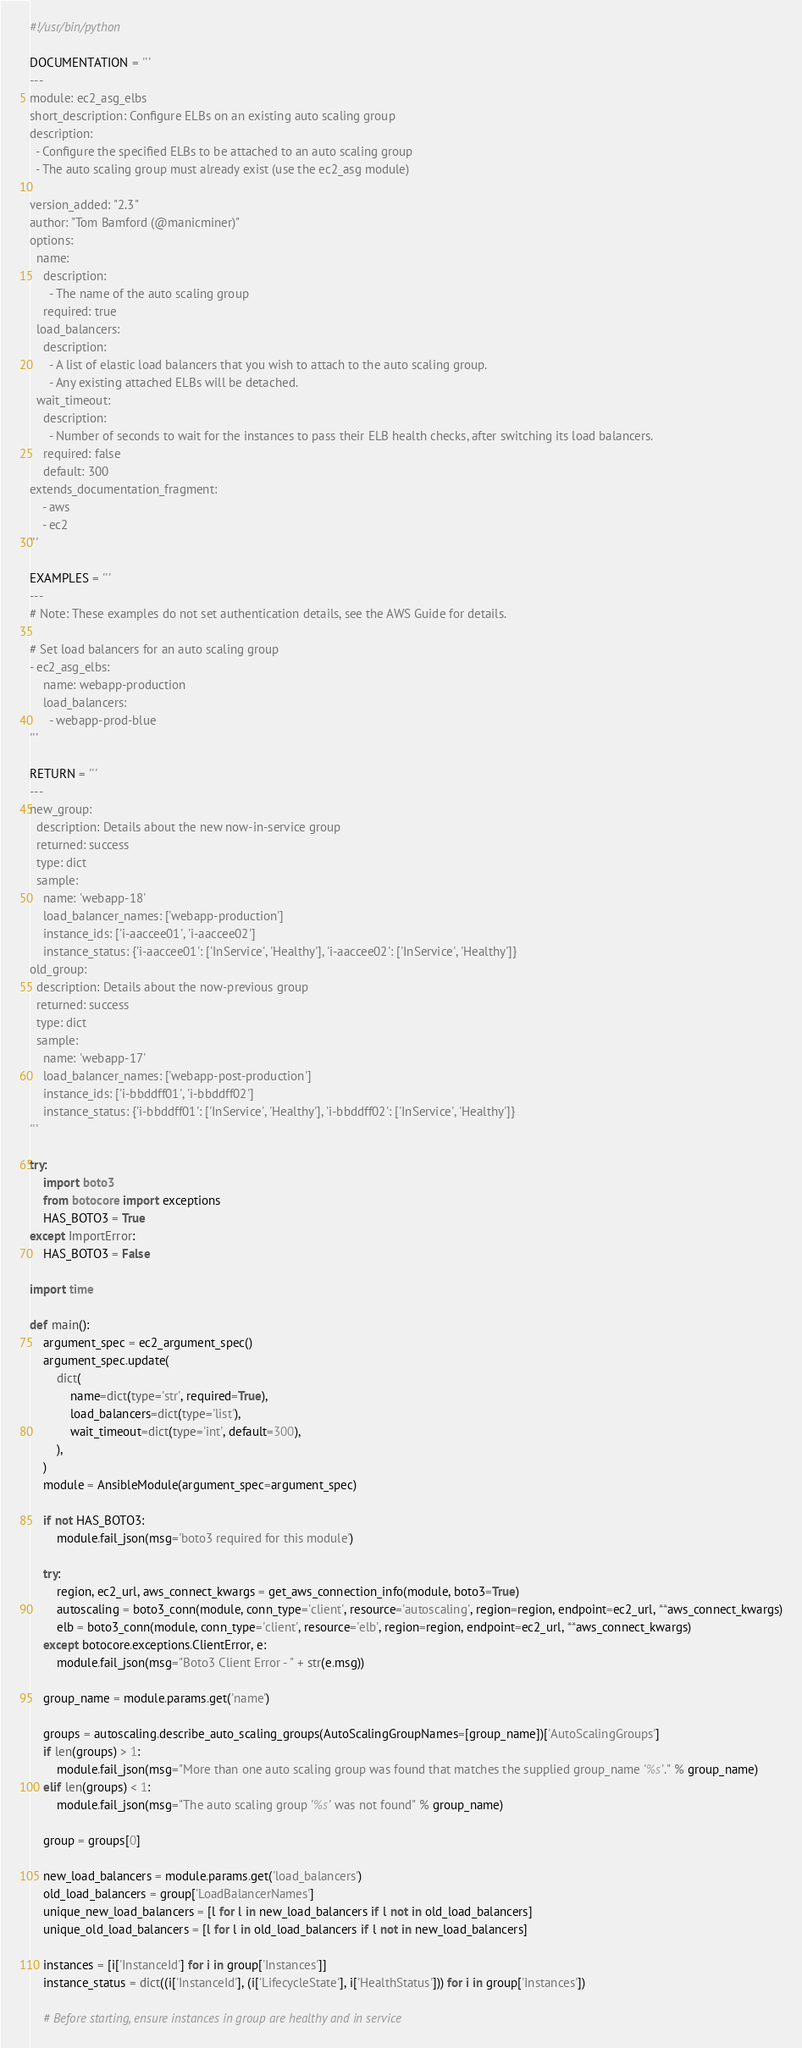Convert code to text. <code><loc_0><loc_0><loc_500><loc_500><_Python_>#!/usr/bin/python

DOCUMENTATION = '''
---
module: ec2_asg_elbs
short_description: Configure ELBs on an existing auto scaling group
description:
  - Configure the specified ELBs to be attached to an auto scaling group
  - The auto scaling group must already exist (use the ec2_asg module)

version_added: "2.3"
author: "Tom Bamford (@manicminer)"
options:
  name:
    description:
      - The name of the auto scaling group
    required: true
  load_balancers:
    description:
      - A list of elastic load balancers that you wish to attach to the auto scaling group.
      - Any existing attached ELBs will be detached.
  wait_timeout:
    description:
      - Number of seconds to wait for the instances to pass their ELB health checks, after switching its load balancers.
    required: false
    default: 300
extends_documentation_fragment:
    - aws
    - ec2
'''

EXAMPLES = '''
---
# Note: These examples do not set authentication details, see the AWS Guide for details.

# Set load balancers for an auto scaling group
- ec2_asg_elbs:
    name: webapp-production
    load_balancers:
      - webapp-prod-blue
'''

RETURN = '''
---
new_group:
  description: Details about the new now-in-service group
  returned: success
  type: dict
  sample:
    name: 'webapp-18'
    load_balancer_names: ['webapp-production']
    instance_ids: ['i-aaccee01', 'i-aaccee02']
    instance_status: {'i-aaccee01': ['InService', 'Healthy'], 'i-aaccee02': ['InService', 'Healthy']}
old_group:
  description: Details about the now-previous group
  returned: success
  type: dict
  sample:
    name: 'webapp-17'
    load_balancer_names: ['webapp-post-production']
    instance_ids: ['i-bbddff01', 'i-bbddff02']
    instance_status: {'i-bbddff01': ['InService', 'Healthy'], 'i-bbddff02': ['InService', 'Healthy']}
'''

try:
    import boto3
    from botocore import exceptions
    HAS_BOTO3 = True
except ImportError:
    HAS_BOTO3 = False

import time

def main():
    argument_spec = ec2_argument_spec()
    argument_spec.update(
        dict(
            name=dict(type='str', required=True),
            load_balancers=dict(type='list'),
            wait_timeout=dict(type='int', default=300),
        ),
    )
    module = AnsibleModule(argument_spec=argument_spec)

    if not HAS_BOTO3:
        module.fail_json(msg='boto3 required for this module')

    try:
        region, ec2_url, aws_connect_kwargs = get_aws_connection_info(module, boto3=True)
        autoscaling = boto3_conn(module, conn_type='client', resource='autoscaling', region=region, endpoint=ec2_url, **aws_connect_kwargs)
        elb = boto3_conn(module, conn_type='client', resource='elb', region=region, endpoint=ec2_url, **aws_connect_kwargs)
    except botocore.exceptions.ClientError, e:
        module.fail_json(msg="Boto3 Client Error - " + str(e.msg))

    group_name = module.params.get('name')

    groups = autoscaling.describe_auto_scaling_groups(AutoScalingGroupNames=[group_name])['AutoScalingGroups']
    if len(groups) > 1:
        module.fail_json(msg="More than one auto scaling group was found that matches the supplied group_name '%s'." % group_name)
    elif len(groups) < 1:
        module.fail_json(msg="The auto scaling group '%s' was not found" % group_name)

    group = groups[0]

    new_load_balancers = module.params.get('load_balancers')
    old_load_balancers = group['LoadBalancerNames']
    unique_new_load_balancers = [l for l in new_load_balancers if l not in old_load_balancers]
    unique_old_load_balancers = [l for l in old_load_balancers if l not in new_load_balancers]

    instances = [i['InstanceId'] for i in group['Instances']]
    instance_status = dict((i['InstanceId'], (i['LifecycleState'], i['HealthStatus'])) for i in group['Instances'])

    # Before starting, ensure instances in group are healthy and in service</code> 